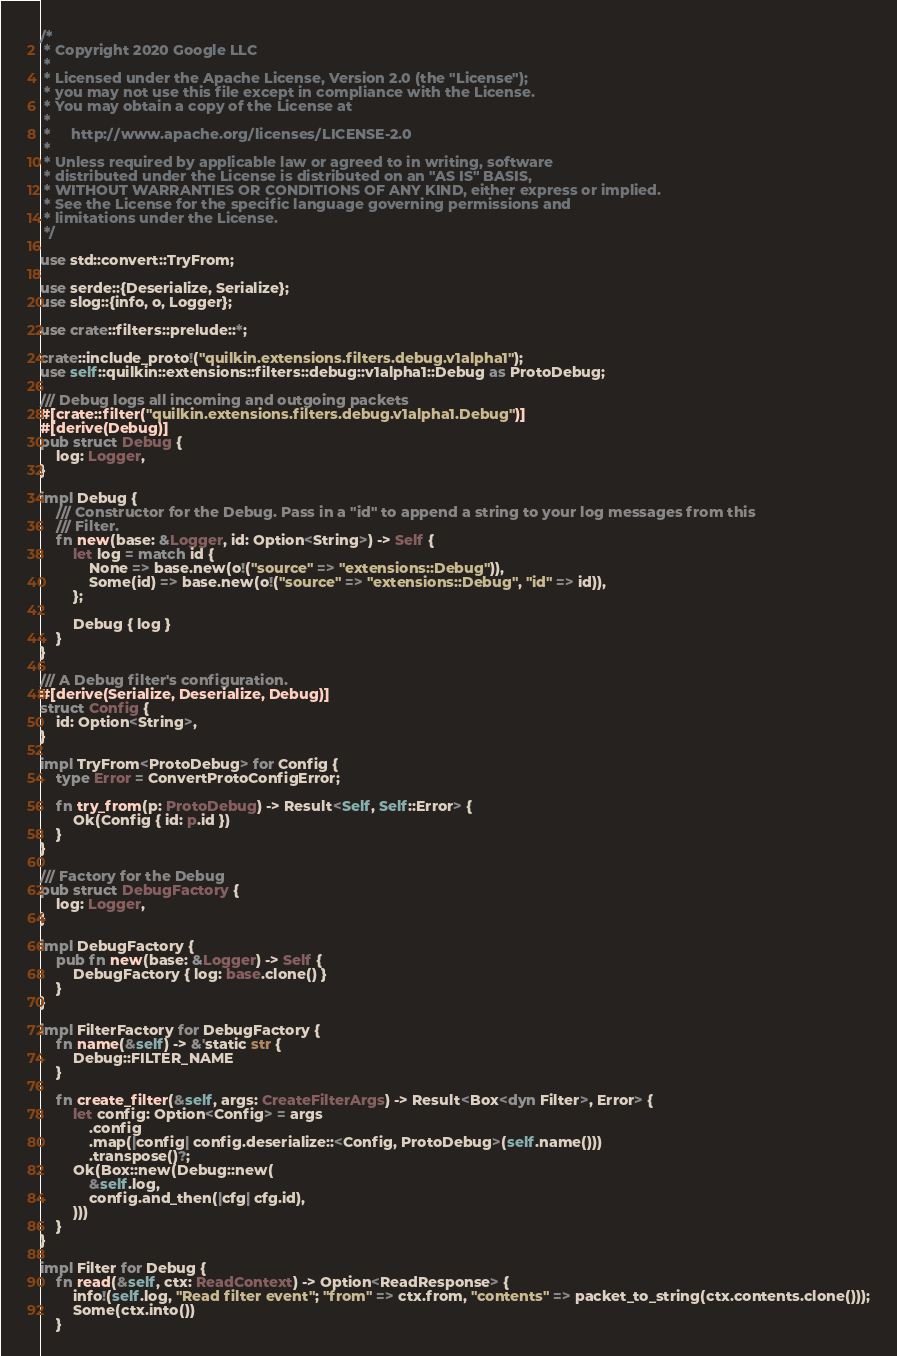<code> <loc_0><loc_0><loc_500><loc_500><_Rust_>/*
 * Copyright 2020 Google LLC
 *
 * Licensed under the Apache License, Version 2.0 (the "License");
 * you may not use this file except in compliance with the License.
 * You may obtain a copy of the License at
 *
 *     http://www.apache.org/licenses/LICENSE-2.0
 *
 * Unless required by applicable law or agreed to in writing, software
 * distributed under the License is distributed on an "AS IS" BASIS,
 * WITHOUT WARRANTIES OR CONDITIONS OF ANY KIND, either express or implied.
 * See the License for the specific language governing permissions and
 * limitations under the License.
 */

use std::convert::TryFrom;

use serde::{Deserialize, Serialize};
use slog::{info, o, Logger};

use crate::filters::prelude::*;

crate::include_proto!("quilkin.extensions.filters.debug.v1alpha1");
use self::quilkin::extensions::filters::debug::v1alpha1::Debug as ProtoDebug;

/// Debug logs all incoming and outgoing packets
#[crate::filter("quilkin.extensions.filters.debug.v1alpha1.Debug")]
#[derive(Debug)]
pub struct Debug {
    log: Logger,
}

impl Debug {
    /// Constructor for the Debug. Pass in a "id" to append a string to your log messages from this
    /// Filter.
    fn new(base: &Logger, id: Option<String>) -> Self {
        let log = match id {
            None => base.new(o!("source" => "extensions::Debug")),
            Some(id) => base.new(o!("source" => "extensions::Debug", "id" => id)),
        };

        Debug { log }
    }
}

/// A Debug filter's configuration.
#[derive(Serialize, Deserialize, Debug)]
struct Config {
    id: Option<String>,
}

impl TryFrom<ProtoDebug> for Config {
    type Error = ConvertProtoConfigError;

    fn try_from(p: ProtoDebug) -> Result<Self, Self::Error> {
        Ok(Config { id: p.id })
    }
}

/// Factory for the Debug
pub struct DebugFactory {
    log: Logger,
}

impl DebugFactory {
    pub fn new(base: &Logger) -> Self {
        DebugFactory { log: base.clone() }
    }
}

impl FilterFactory for DebugFactory {
    fn name(&self) -> &'static str {
        Debug::FILTER_NAME
    }

    fn create_filter(&self, args: CreateFilterArgs) -> Result<Box<dyn Filter>, Error> {
        let config: Option<Config> = args
            .config
            .map(|config| config.deserialize::<Config, ProtoDebug>(self.name()))
            .transpose()?;
        Ok(Box::new(Debug::new(
            &self.log,
            config.and_then(|cfg| cfg.id),
        )))
    }
}

impl Filter for Debug {
    fn read(&self, ctx: ReadContext) -> Option<ReadResponse> {
        info!(self.log, "Read filter event"; "from" => ctx.from, "contents" => packet_to_string(ctx.contents.clone()));
        Some(ctx.into())
    }
</code> 